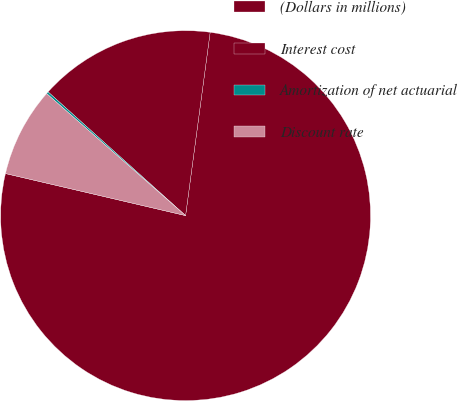Convert chart. <chart><loc_0><loc_0><loc_500><loc_500><pie_chart><fcel>(Dollars in millions)<fcel>Interest cost<fcel>Amortization of net actuarial<fcel>Discount rate<nl><fcel>76.53%<fcel>15.46%<fcel>0.19%<fcel>7.82%<nl></chart> 